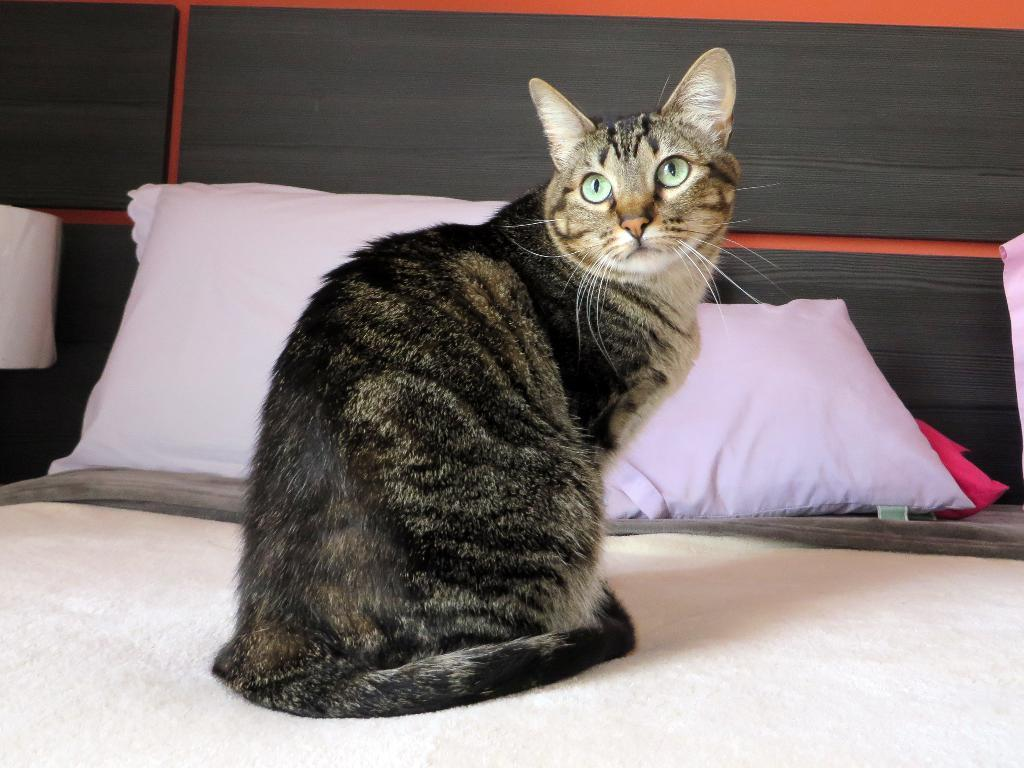What animal is located in the middle of the image? There is a cat in the middle of the image. What can be seen in the background of the image? There are pillows in the background of the image. What type of polish is the cat using in the image? There is no polish present in the image, and the cat is not using any polish. 